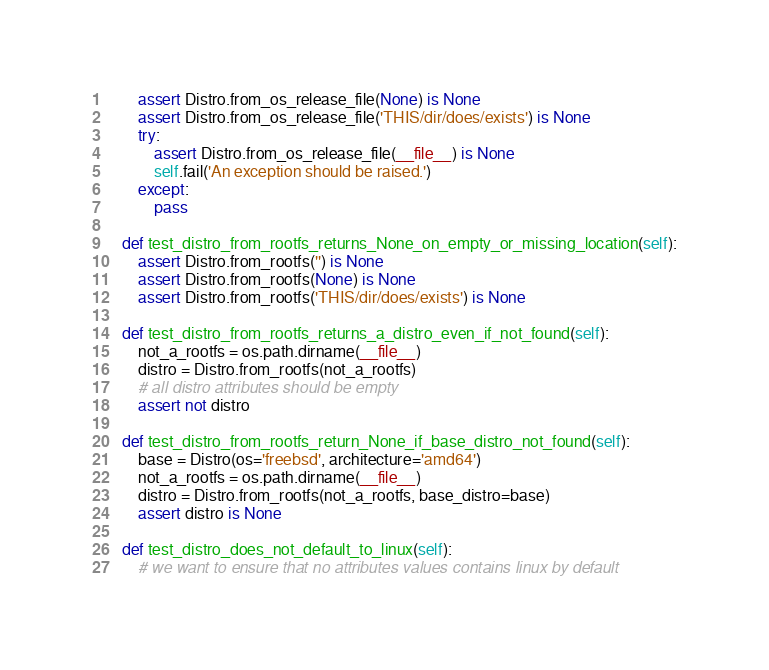Convert code to text. <code><loc_0><loc_0><loc_500><loc_500><_Python_>        assert Distro.from_os_release_file(None) is None
        assert Distro.from_os_release_file('THIS/dir/does/exists') is None
        try:
            assert Distro.from_os_release_file(__file__) is None
            self.fail('An exception should be raised.')
        except:
            pass

    def test_distro_from_rootfs_returns_None_on_empty_or_missing_location(self):
        assert Distro.from_rootfs('') is None
        assert Distro.from_rootfs(None) is None
        assert Distro.from_rootfs('THIS/dir/does/exists') is None

    def test_distro_from_rootfs_returns_a_distro_even_if_not_found(self):
        not_a_rootfs = os.path.dirname(__file__)
        distro = Distro.from_rootfs(not_a_rootfs)
        # all distro attributes should be empty
        assert not distro

    def test_distro_from_rootfs_return_None_if_base_distro_not_found(self):
        base = Distro(os='freebsd', architecture='amd64')
        not_a_rootfs = os.path.dirname(__file__)
        distro = Distro.from_rootfs(not_a_rootfs, base_distro=base)
        assert distro is None

    def test_distro_does_not_default_to_linux(self):
        # we want to ensure that no attributes values contains linux by default</code> 